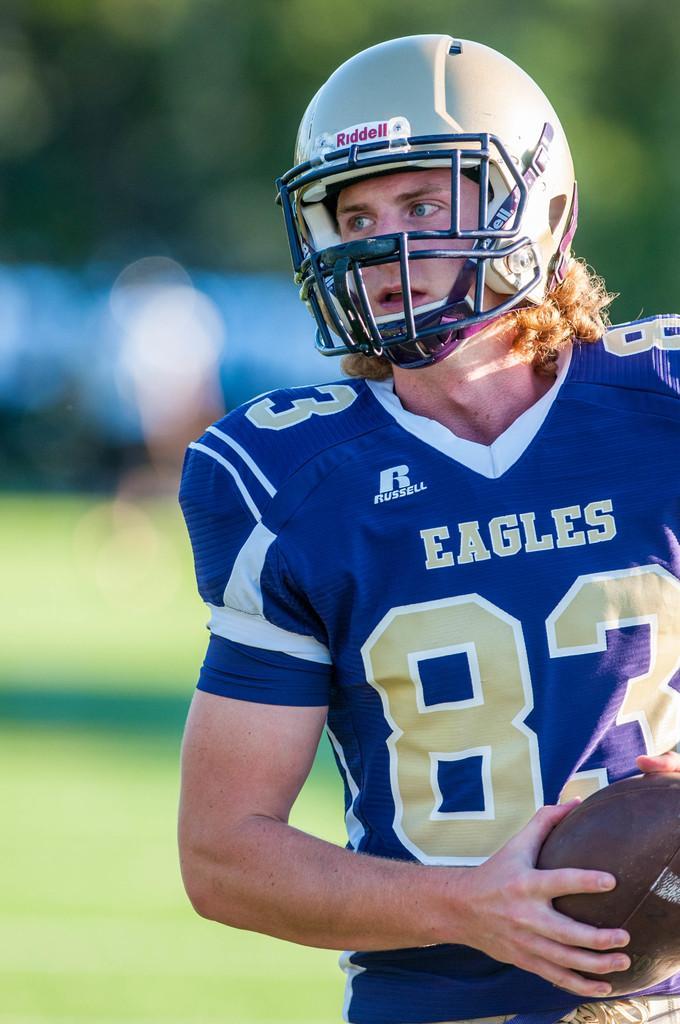Please provide a concise description of this image. In this image we can see a man wearing a sports dress and holding a ball and also we can see he is wearing a helmet and in the background the image is blurred. 